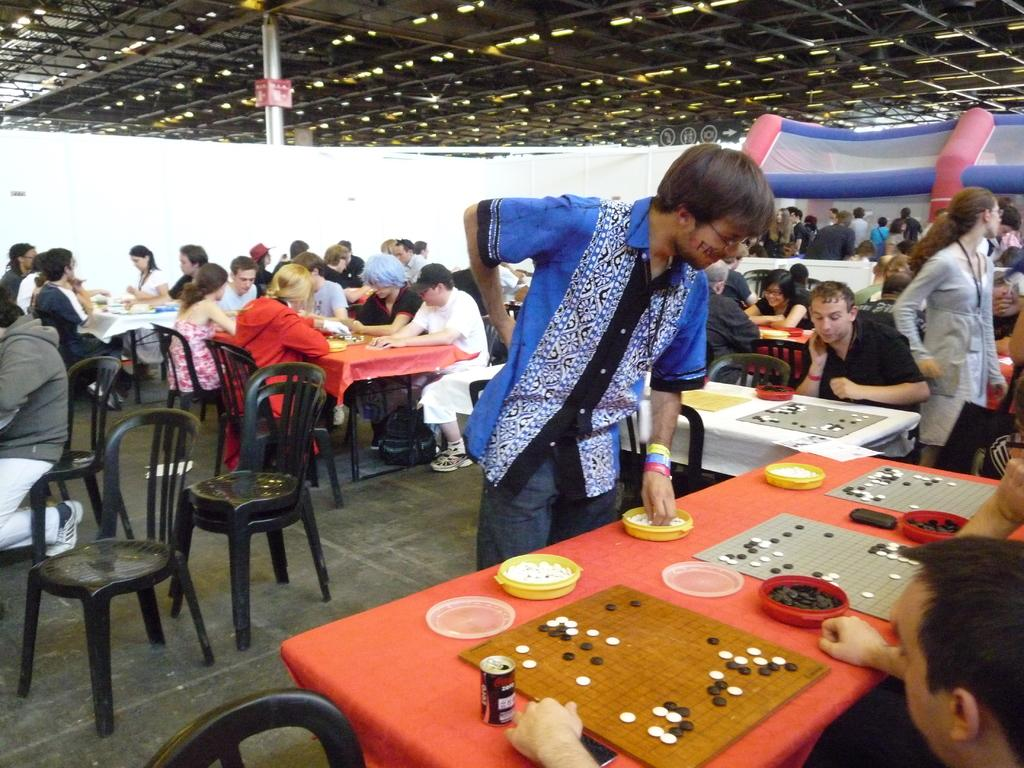What are the people in the image doing? There are people sitting and standing in the image. What objects are present in the image that might be used for placing items or eating? There are tables in the image. What type of music is being played in the image? There is no information about music being played in the image. How does the beef look in the image? There is no beef present in the image. 